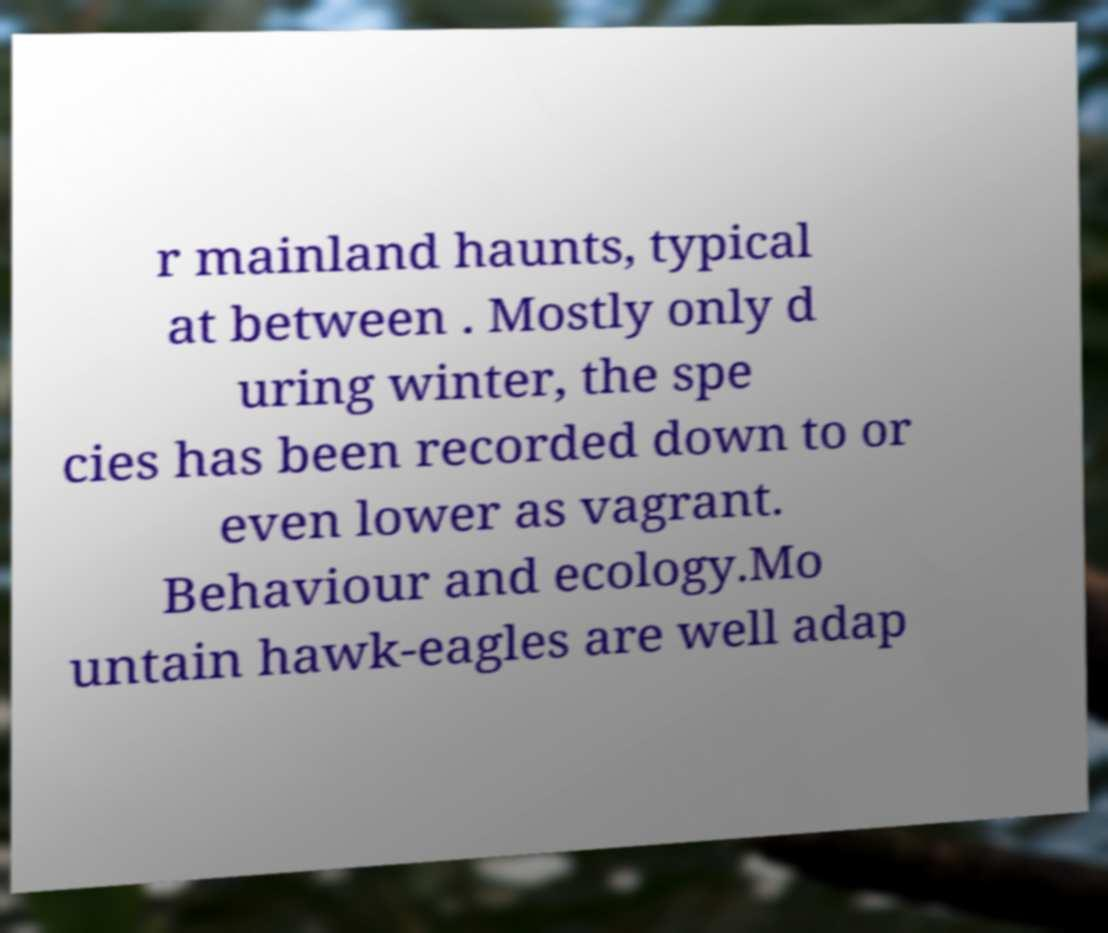Could you extract and type out the text from this image? r mainland haunts, typical at between . Mostly only d uring winter, the spe cies has been recorded down to or even lower as vagrant. Behaviour and ecology.Mo untain hawk-eagles are well adap 